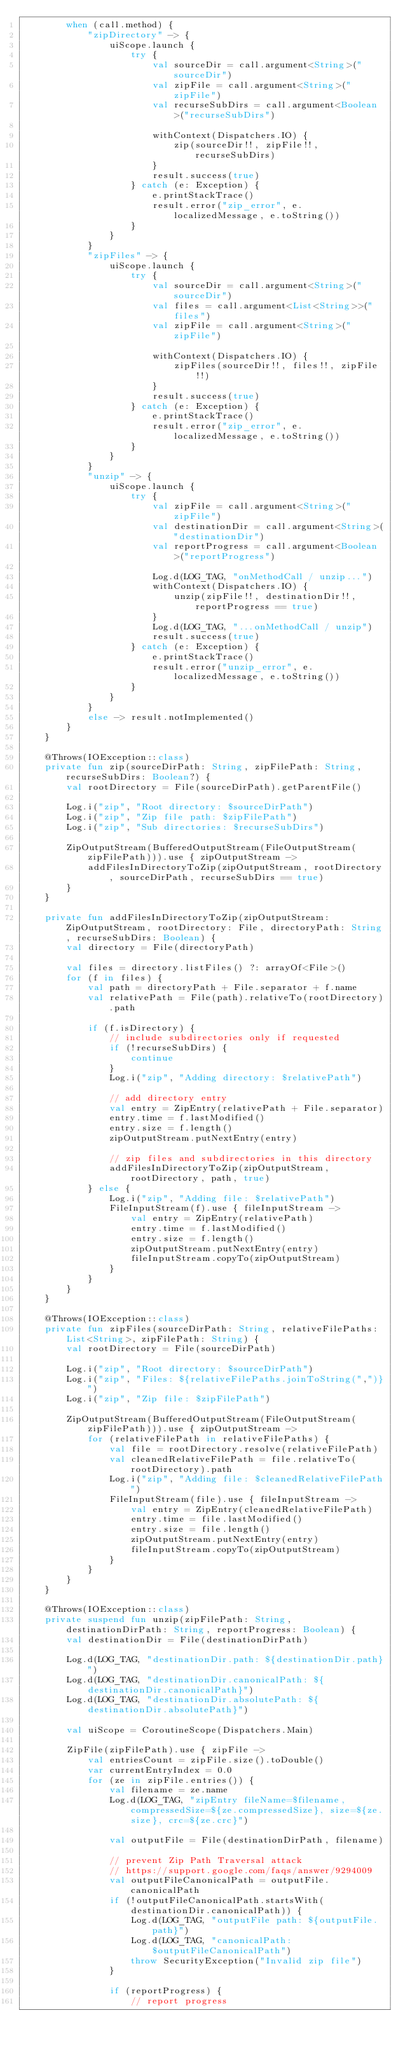<code> <loc_0><loc_0><loc_500><loc_500><_Kotlin_>        when (call.method) {
            "zipDirectory" -> {
                uiScope.launch {
                    try {
                        val sourceDir = call.argument<String>("sourceDir")
                        val zipFile = call.argument<String>("zipFile")
                        val recurseSubDirs = call.argument<Boolean>("recurseSubDirs")

                        withContext(Dispatchers.IO) {
                            zip(sourceDir!!, zipFile!!, recurseSubDirs)
                        }
                        result.success(true)
                    } catch (e: Exception) {
                        e.printStackTrace()
                        result.error("zip_error", e.localizedMessage, e.toString())
                    }
                }
            }
            "zipFiles" -> {
                uiScope.launch {
                    try {
                        val sourceDir = call.argument<String>("sourceDir")
                        val files = call.argument<List<String>>("files")
                        val zipFile = call.argument<String>("zipFile")

                        withContext(Dispatchers.IO) {
                            zipFiles(sourceDir!!, files!!, zipFile!!)
                        }
                        result.success(true)
                    } catch (e: Exception) {
                        e.printStackTrace()
                        result.error("zip_error", e.localizedMessage, e.toString())
                    }
                }
            }
            "unzip" -> {
                uiScope.launch {
                    try {
                        val zipFile = call.argument<String>("zipFile")
                        val destinationDir = call.argument<String>("destinationDir")
                        val reportProgress = call.argument<Boolean>("reportProgress")

                        Log.d(LOG_TAG, "onMethodCall / unzip...")
                        withContext(Dispatchers.IO) {
                            unzip(zipFile!!, destinationDir!!, reportProgress == true)
                        }
                        Log.d(LOG_TAG, "...onMethodCall / unzip")
                        result.success(true)
                    } catch (e: Exception) {
                        e.printStackTrace()
                        result.error("unzip_error", e.localizedMessage, e.toString())
                    }
                }
            }
            else -> result.notImplemented()
        }
    }

    @Throws(IOException::class)
    private fun zip(sourceDirPath: String, zipFilePath: String, recurseSubDirs: Boolean?) {
        val rootDirectory = File(sourceDirPath).getParentFile()

        Log.i("zip", "Root directory: $sourceDirPath")
        Log.i("zip", "Zip file path: $zipFilePath")
        Log.i("zip", "Sub directories: $recurseSubDirs")

        ZipOutputStream(BufferedOutputStream(FileOutputStream(zipFilePath))).use { zipOutputStream ->
            addFilesInDirectoryToZip(zipOutputStream, rootDirectory, sourceDirPath, recurseSubDirs == true)
        }
    }

    private fun addFilesInDirectoryToZip(zipOutputStream: ZipOutputStream, rootDirectory: File, directoryPath: String, recurseSubDirs: Boolean) {
        val directory = File(directoryPath)

        val files = directory.listFiles() ?: arrayOf<File>()
        for (f in files) {
            val path = directoryPath + File.separator + f.name
            val relativePath = File(path).relativeTo(rootDirectory).path

            if (f.isDirectory) {
                // include subdirectories only if requested
                if (!recurseSubDirs) {
                    continue
                }
                Log.i("zip", "Adding directory: $relativePath")

                // add directory entry
                val entry = ZipEntry(relativePath + File.separator)
                entry.time = f.lastModified()
                entry.size = f.length()
                zipOutputStream.putNextEntry(entry)

                // zip files and subdirectories in this directory
                addFilesInDirectoryToZip(zipOutputStream, rootDirectory, path, true)
            } else {
                Log.i("zip", "Adding file: $relativePath")
                FileInputStream(f).use { fileInputStream ->
                    val entry = ZipEntry(relativePath)
                    entry.time = f.lastModified()
                    entry.size = f.length()
                    zipOutputStream.putNextEntry(entry)
                    fileInputStream.copyTo(zipOutputStream)
                }
            }
        }
    }

    @Throws(IOException::class)
    private fun zipFiles(sourceDirPath: String, relativeFilePaths: List<String>, zipFilePath: String) {
        val rootDirectory = File(sourceDirPath)

        Log.i("zip", "Root directory: $sourceDirPath")
        Log.i("zip", "Files: ${relativeFilePaths.joinToString(",")}")
        Log.i("zip", "Zip file: $zipFilePath")

        ZipOutputStream(BufferedOutputStream(FileOutputStream(zipFilePath))).use { zipOutputStream ->
            for (relativeFilePath in relativeFilePaths) {
                val file = rootDirectory.resolve(relativeFilePath)
                val cleanedRelativeFilePath = file.relativeTo(rootDirectory).path
                Log.i("zip", "Adding file: $cleanedRelativeFilePath")
                FileInputStream(file).use { fileInputStream ->
                    val entry = ZipEntry(cleanedRelativeFilePath)
                    entry.time = file.lastModified()
                    entry.size = file.length()
                    zipOutputStream.putNextEntry(entry)
                    fileInputStream.copyTo(zipOutputStream)
                }
            }
        }
    }

    @Throws(IOException::class)
    private suspend fun unzip(zipFilePath: String, destinationDirPath: String, reportProgress: Boolean) {
        val destinationDir = File(destinationDirPath)

        Log.d(LOG_TAG, "destinationDir.path: ${destinationDir.path}")
        Log.d(LOG_TAG, "destinationDir.canonicalPath: ${destinationDir.canonicalPath}")
        Log.d(LOG_TAG, "destinationDir.absolutePath: ${destinationDir.absolutePath}")

        val uiScope = CoroutineScope(Dispatchers.Main)

        ZipFile(zipFilePath).use { zipFile ->
            val entriesCount = zipFile.size().toDouble()
            var currentEntryIndex = 0.0
            for (ze in zipFile.entries()) {
                val filename = ze.name
                Log.d(LOG_TAG, "zipEntry fileName=$filename, compressedSize=${ze.compressedSize}, size=${ze.size}, crc=${ze.crc}")

                val outputFile = File(destinationDirPath, filename)

                // prevent Zip Path Traversal attack
                // https://support.google.com/faqs/answer/9294009
                val outputFileCanonicalPath = outputFile.canonicalPath
                if (!outputFileCanonicalPath.startsWith(destinationDir.canonicalPath)) {
                    Log.d(LOG_TAG, "outputFile path: ${outputFile.path}")
                    Log.d(LOG_TAG, "canonicalPath: $outputFileCanonicalPath")
                    throw SecurityException("Invalid zip file")
                }

                if (reportProgress) {
                    // report progress</code> 